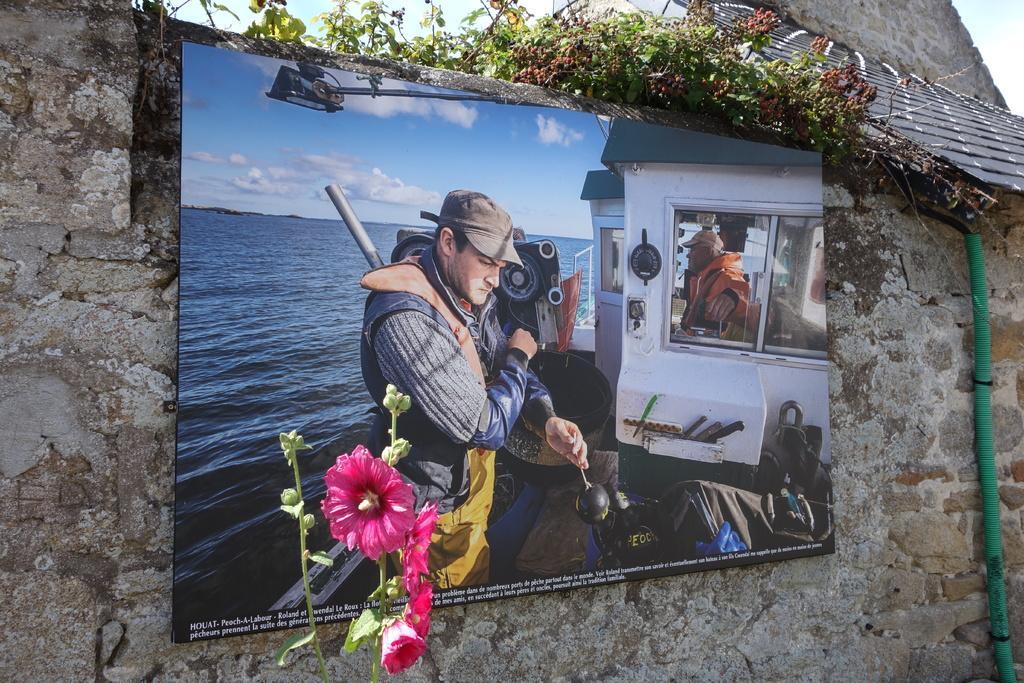How would you summarize this image in a sentence or two? In the picture I can see a wall which has board attached to it. In the board I can see photos of people on a boat. The boat on the water. In the background I can the sky. 